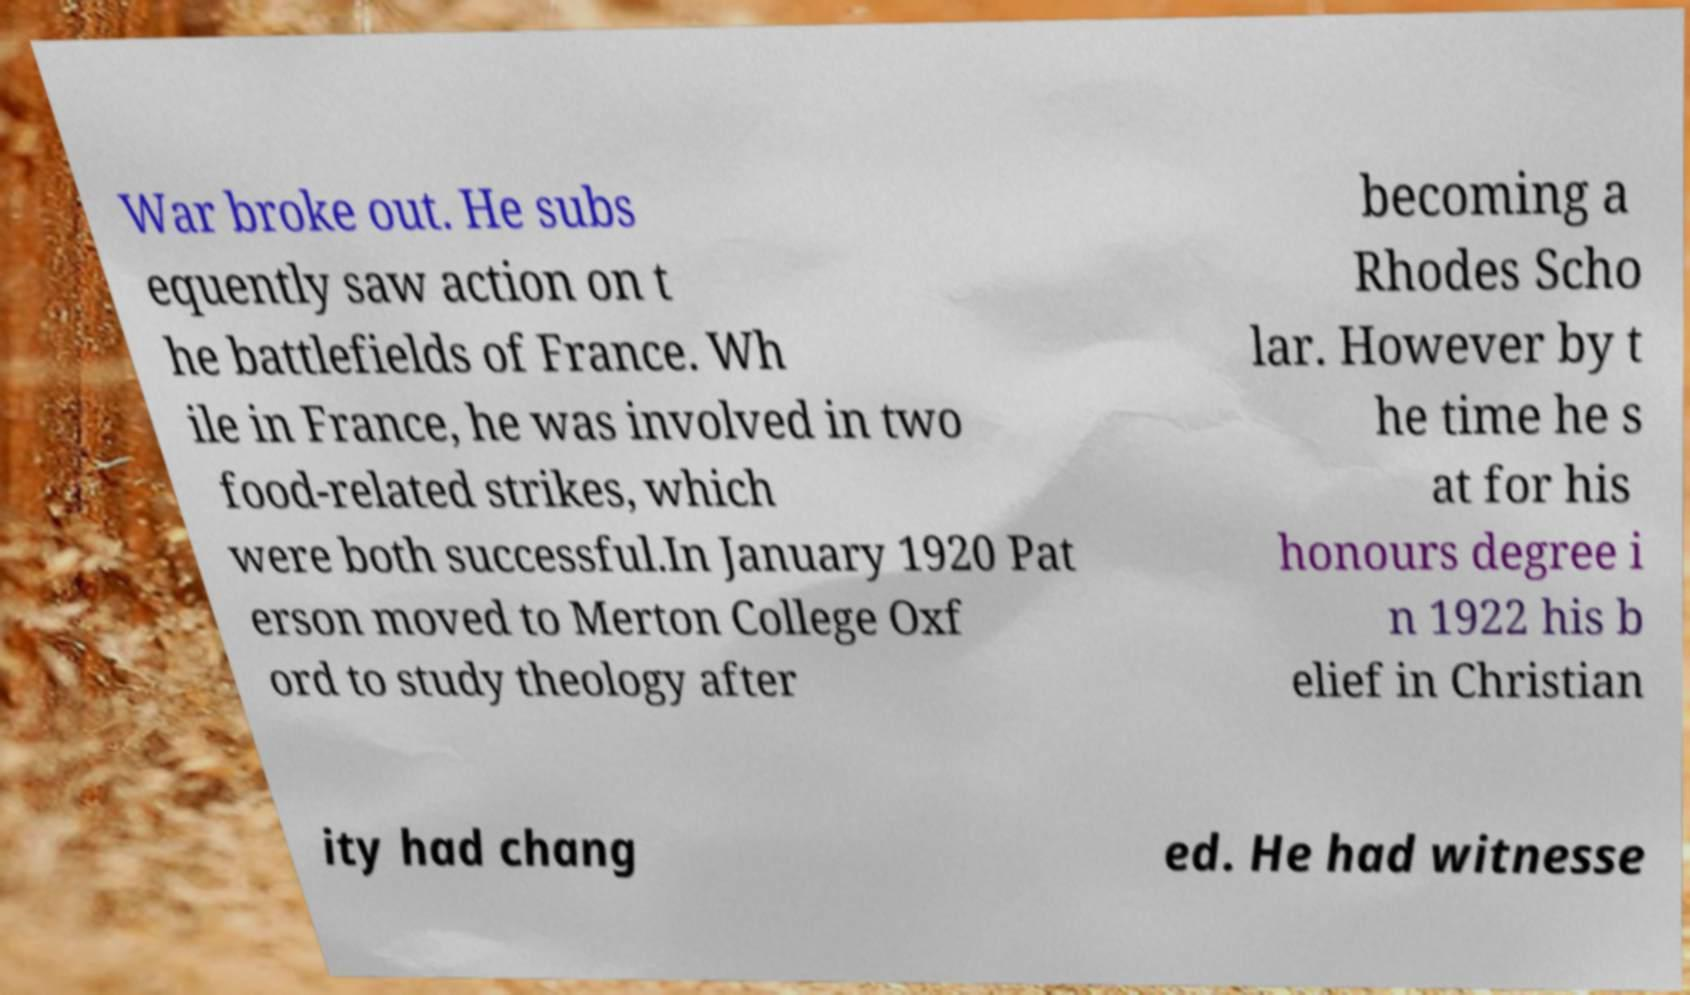Could you assist in decoding the text presented in this image and type it out clearly? War broke out. He subs equently saw action on t he battlefields of France. Wh ile in France, he was involved in two food-related strikes, which were both successful.In January 1920 Pat erson moved to Merton College Oxf ord to study theology after becoming a Rhodes Scho lar. However by t he time he s at for his honours degree i n 1922 his b elief in Christian ity had chang ed. He had witnesse 